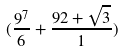Convert formula to latex. <formula><loc_0><loc_0><loc_500><loc_500>( \frac { 9 ^ { 7 } } { 6 } + \frac { 9 2 + \sqrt { 3 } } { 1 } )</formula> 